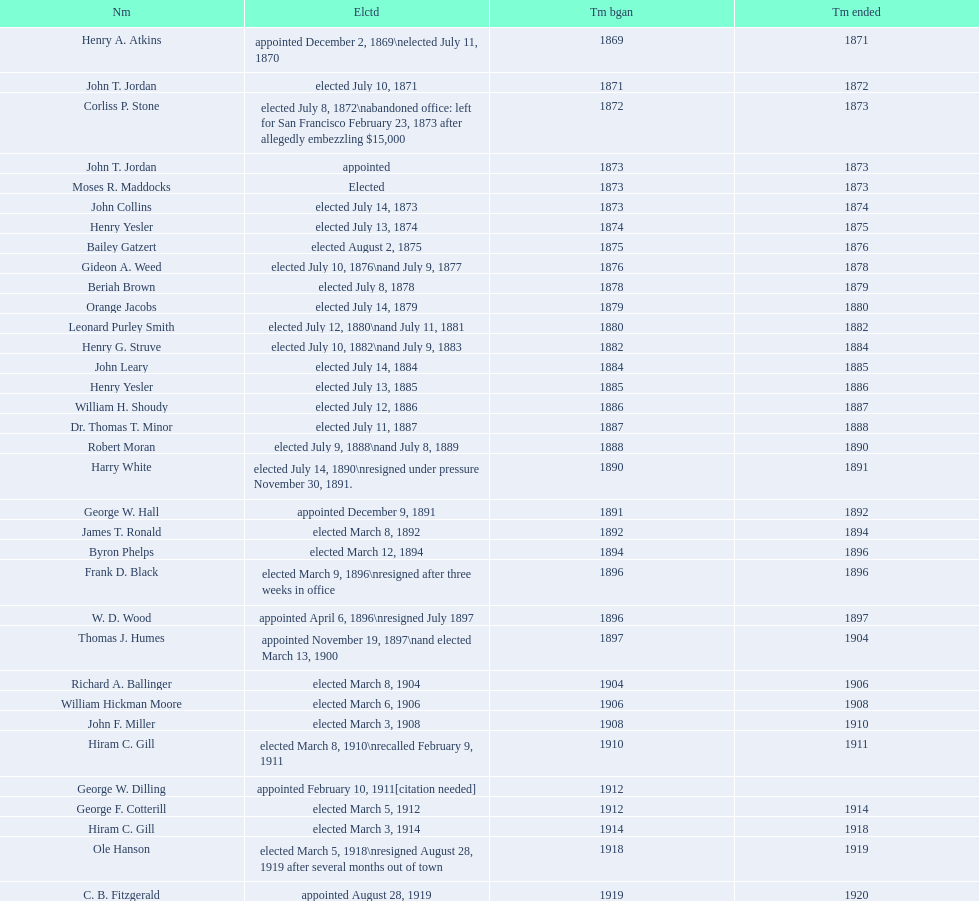Who was the only person elected in 1871? John T. Jordan. 